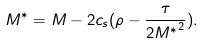Convert formula to latex. <formula><loc_0><loc_0><loc_500><loc_500>M ^ { * } = M - 2 c _ { s } ( \rho - \frac { \tau } { { 2 M ^ { * } } ^ { 2 } } ) .</formula> 